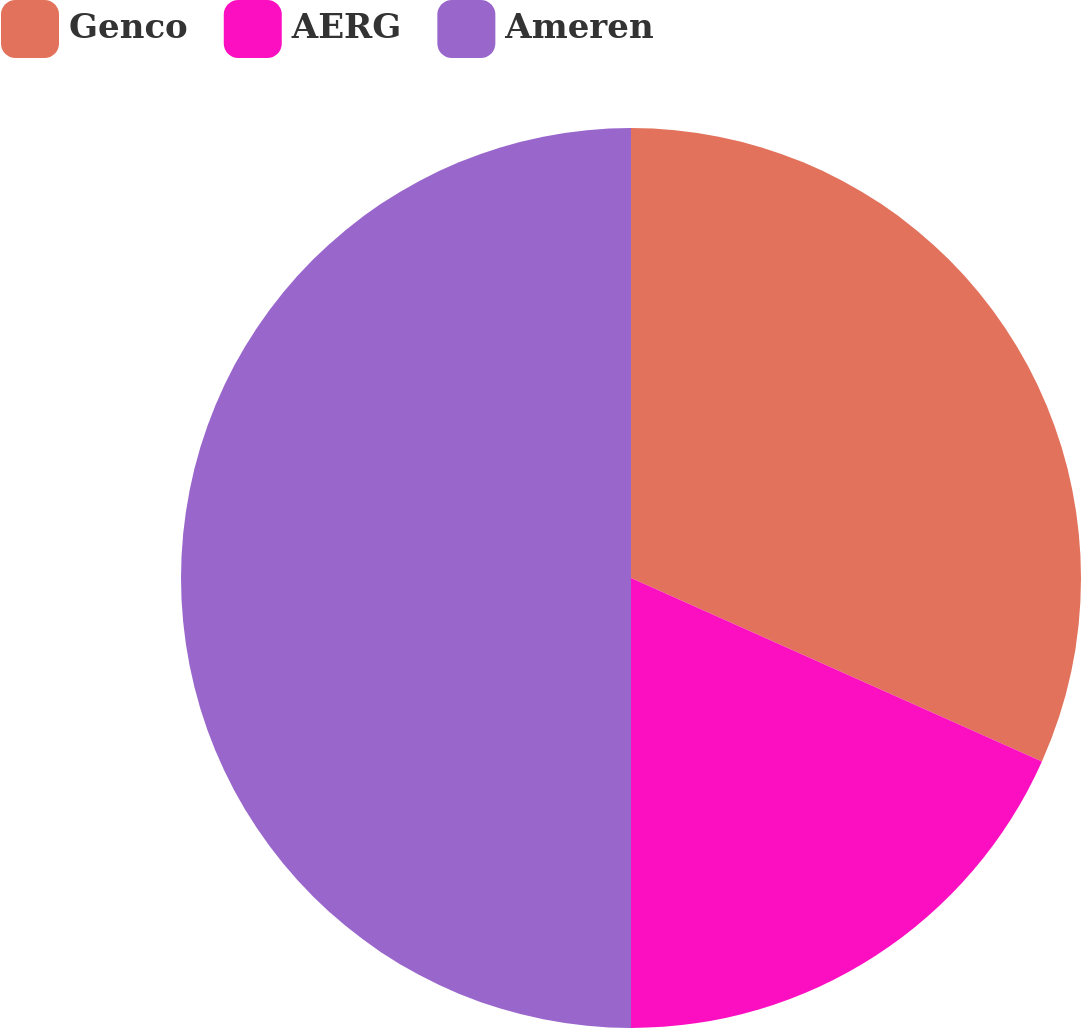Convert chart. <chart><loc_0><loc_0><loc_500><loc_500><pie_chart><fcel>Genco<fcel>AERG<fcel>Ameren<nl><fcel>31.68%<fcel>18.32%<fcel>50.0%<nl></chart> 